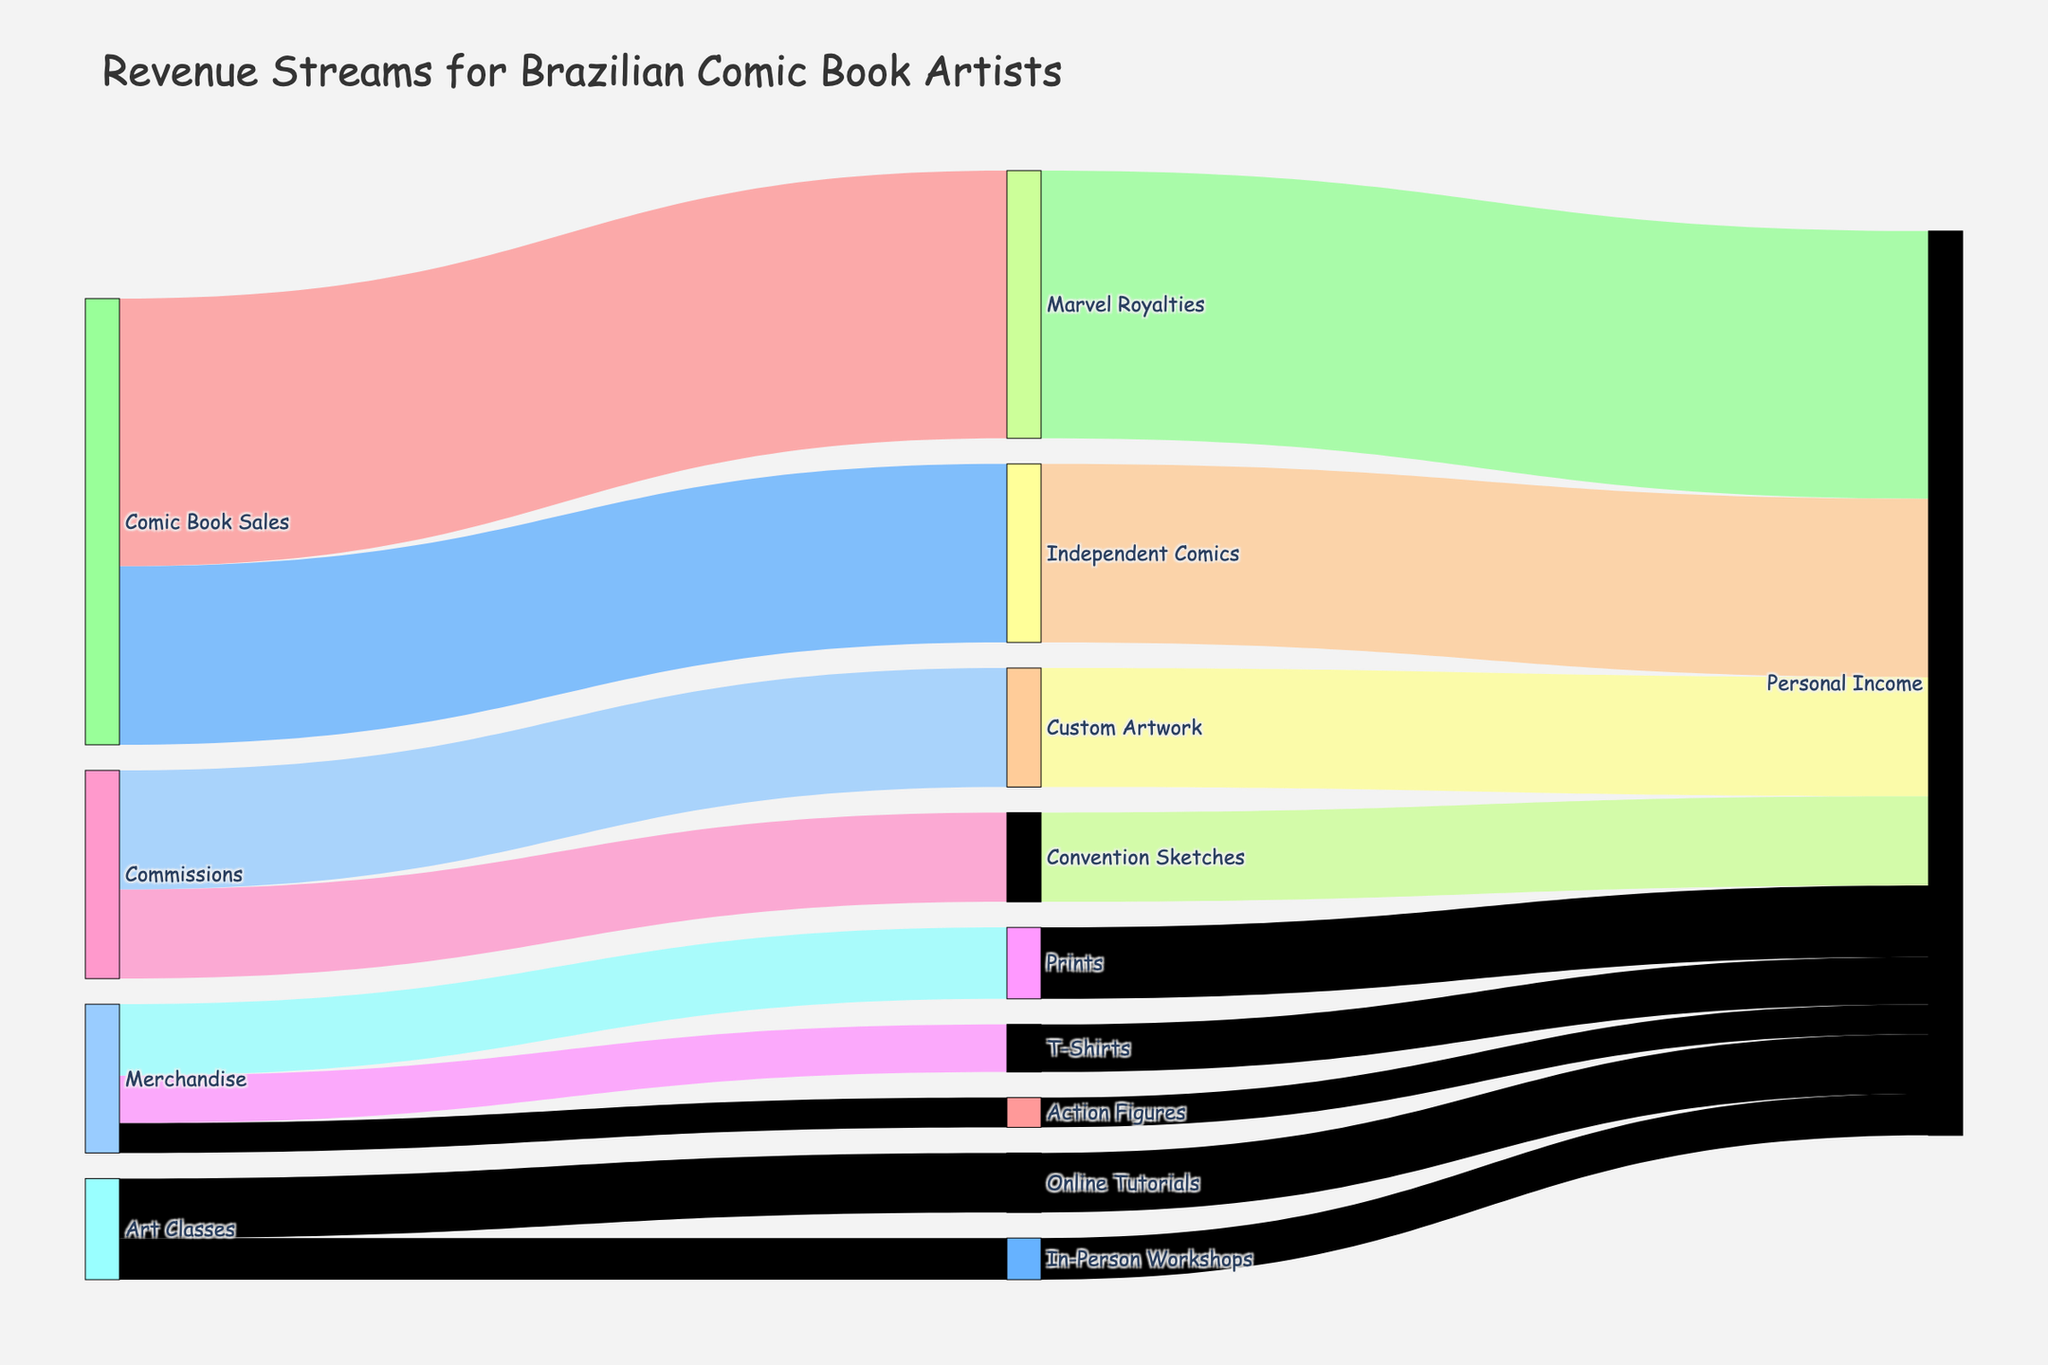What are the primary sources of revenue for Brazilian comic book artists? Look at the nodes that don't show as targets. The main sources are "Comic Book Sales", "Commissions", "Merchandise", and "Art Classes".
Answer: Comic Book Sales, Commissions, Merchandise, Art Classes How much revenue comes from Marvel Royalties? Follow the flow from "Comic Book Sales" to "Marvel Royalties". The value is 45,000.
Answer: 45,000 Which revenue stream under Commissions contributes more to personal income? Compare the values of "Convention Sketches" and "Custom Artwork", which are both under "Commissions". "Custom Artwork" has a greater value of 20,000 vs. 15,000 for "Convention Sketches".
Answer: Custom Artwork What is the total amount of revenue from Merchandise flows? Sum the values sourced by Merchandise: 8000 (T-Shirts) + 12000 (Prints) + 5000 (Action Figures).
Answer: 25,000 Are there any revenue streams that do not directly contribute to personal income? Identify nodes that do not flow directly into "Personal Income". All streams (Marvel Royalties, Independent Comics, Convention Sketches, Custom Artwork, T-Shirts, Prints, Action Figures, Online Tutorials, In-Person Workshops) tie into "Personal Income".
Answer: No What fraction of total revenue comes from Commissions? Sum the values under Commissions: Convention Sketches (15,000) and Custom Artwork (20,000). Total commission is 35,000. Sum up the total modeled revenue: 45,000 (Marvel Royalties) + 30,000 (Independent Comics) + 15,000 (Convention Sketches) + 20,000 (Custom Artwork) + 8,000 (T-Shirts) + 12,000 (Prints) + 5,000 (Action Figures) + 10,000 (Online Tutorials) + 7,000 (In-Person Workshops) = 152,000. Fraction is 35,000/152,000.
Answer: About 23% What is the revenue percentage of "Prints" among Merchandise? "Prints" have a value of 12,000. Sum the total for Merchandise (8,000 + 12,000 + 5,000). "Prints" percentage is (12,000 / 25,000) * 100.
Answer: 48% How does the revenue from "In-Person Workshops" compare to "Online Tutorials"? Compare the value linked to each: "In-Person Workshops" is 7,000 and "Online Tutorials" is 10,000.
Answer: Online Tutorials generate more What is the total personal income from all sources? Sum all values directed to "Personal Income": 45,000 + 30,000 + 15,000 + 20,000 + 8,000 + 12,000 + 5,000 + 10,000 + 7,000.
Answer: 152,000 Which contributes more to personal income: Comic Book Sales or Art Classes? Compare the sums of their contributions. For Comic Book Sales, it is the sum of "Marvel Royalties" (45,000) and "Independent Comics" (30,000) = 75,000. For Art Classes, sum "Online Tutorials" (10,000) and "In-Person Workshops" (7,000) = 17,000.
Answer: Comic Book Sales 